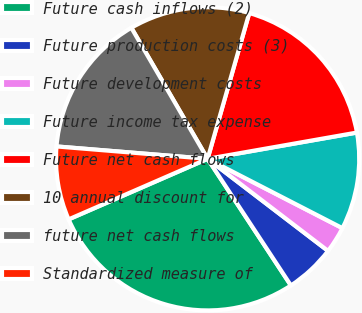<chart> <loc_0><loc_0><loc_500><loc_500><pie_chart><fcel>Future cash inflows (2)<fcel>Future production costs (3)<fcel>Future development costs<fcel>Future income tax expense<fcel>Future net cash flows<fcel>10 annual discount for<fcel>future net cash flows<fcel>Standardized measure of<nl><fcel>27.72%<fcel>5.35%<fcel>2.83%<fcel>10.33%<fcel>17.8%<fcel>12.82%<fcel>15.31%<fcel>7.84%<nl></chart> 